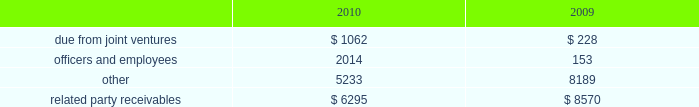Amounts due from related parties at december a031 , 2010 and 2009 con- sisted of the following ( in thousands ) : .
Gramercy capital corp .
See note a0 6 , 201cinvestment in unconsolidated joint ventures 2014gramercy capital corp. , 201d for disclosure on related party transactions between gramercy and the company .
13 2002equit y common stock our authorized capital stock consists of 260000000 shares , $ .01 par value , of which we have authorized the issuance of up to 160000000 shares of common stock , $ .01 par value per share , 75000000 shares of excess stock , $ .01 par value per share , and 25000000 shares of preferred stock , $ .01 par value per share .
As of december a031 , 2010 , 78306702 shares of common stock and no shares of excess stock were issued and outstanding .
In may 2009 , we sold 19550000 shares of our common stock at a gross price of $ 20.75 per share .
The net proceeds from this offer- ing ( approximately $ 387.1 a0 million ) were primarily used to repurchase unsecured debt .
Perpetual preferred stock in january 2010 , we sold 5400000 shares of our series a0c preferred stock in an underwritten public offering .
As a result of this offering , we have 11700000 shares of the series a0 c preferred stock outstanding .
The shares of series a0c preferred stock have a liquidation preference of $ 25.00 per share and are redeemable at par , plus accrued and unpaid dividends , at any time at our option .
The shares were priced at $ 23.53 per share including accrued dividends equating to a yield of 8.101% ( 8.101 % ) .
We used the net offering proceeds of approximately $ 122.0 a0million for gen- eral corporate and/or working capital purposes , including purchases of the indebtedness of our subsidiaries and investment opportunities .
In december 2003 , we sold 6300000 shares of our 7.625% ( 7.625 % ) series a0 c preferred stock , ( including the underwriters 2019 over-allotment option of 700000 shares ) with a mandatory liquidation preference of $ 25.00 per share .
Net proceeds from this offering ( approximately $ 152.0 a0 million ) were used principally to repay amounts outstanding under our secured and unsecured revolving credit facilities .
The series a0c preferred stockholders receive annual dividends of $ 1.90625 per share paid on a quarterly basis and dividends are cumulative , subject to cer- tain provisions .
Since december a0 12 , 2008 , we have been entitled to redeem the series a0c preferred stock at par for cash at our option .
The series a0c preferred stock was recorded net of underwriters discount and issuance costs .
12 2002related part y transactions cleaning/securit y/messenger and restoration services through al l iance bui lding services , or al l iance , first qual i t y maintenance , a0l.p. , or first quality , provides cleaning , extermination and related services , classic security a0llc provides security services , bright star couriers a0llc provides messenger services , and onyx restoration works provides restoration services with respect to certain proper- ties owned by us .
Alliance is partially owned by gary green , a son of stephen a0l .
Green , the chairman of our board of directors .
In addition , first quality has the non-exclusive opportunity to provide cleaning and related services to individual tenants at our properties on a basis sepa- rately negotiated with any tenant seeking such additional services .
The service corp .
Has entered into an arrangement with alliance whereby it will receive a profit participation above a certain threshold for services provided by alliance to certain tenants at certain buildings above the base services specified in their lease agreements .
Alliance paid the service corporation approximately $ 2.2 a0million , $ 1.8 a0million and $ 1.4 a0million for the years ended december a031 , 2010 , 2009 and 2008 , respectively .
We paid alliance approximately $ 14.2 a0million , $ 14.9 a0million and $ 15.1 a0million for three years ended december a031 , 2010 , respectively , for these ser- vices ( excluding services provided directly to tenants ) .
Leases nancy peck and company leases 1003 square feet of space at 420 lexington avenue under a lease that ends in august 2015 .
Nancy peck and company is owned by nancy peck , the wife of stephen a0l .
Green .
The rent due pursuant to the lease is $ 35516 per annum for year one increas- ing to $ 40000 in year seven .
From february 2007 through december 2008 , nancy peck and company leased 507 square feet of space at 420 a0 lexington avenue pursuant to a lease which provided for annual rental payments of approximately $ 15210 .
Brokerage services cushman a0 & wakefield sonnenblick-goldman , a0 llc , or sonnenblick , a nationally recognized real estate investment banking firm , provided mortgage brokerage services to us .
Mr . a0 morton holliday , the father of mr . a0 marc holliday , was a managing director of sonnenblick at the time of the financings .
In 2009 , we paid approximately $ 428000 to sonnenblick in connection with the purchase of a sub-leasehold interest and the refinancing of 420 lexington avenue .
Management fees s.l .
Green management corp. , a consolidated entity , receives property management fees from an entity in which stephen a0l .
Green owns an inter- est .
The aggregate amount of fees paid to s.l .
Green management corp .
From such entity was approximately $ 390700 in 2010 , $ 351700 in 2009 and $ 353500 in 2008 .
Notes to consolidated financial statements .
How much per square foot per month does nancy peck and company charge for its 420 lexington avenue property? 
Computations: (35516 / 12)
Answer: 2959.66667. 